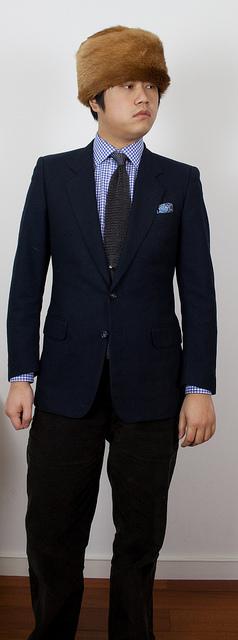What color is the hat?
Concise answer only. Brown. What material is the hat made of?
Write a very short answer. Fur. Where are his hands?
Short answer required. Side. Does his suit match?
Answer briefly. Yes. What color is his shirt?
Write a very short answer. Blue. Which button is undone?
Give a very brief answer. Bottom. 